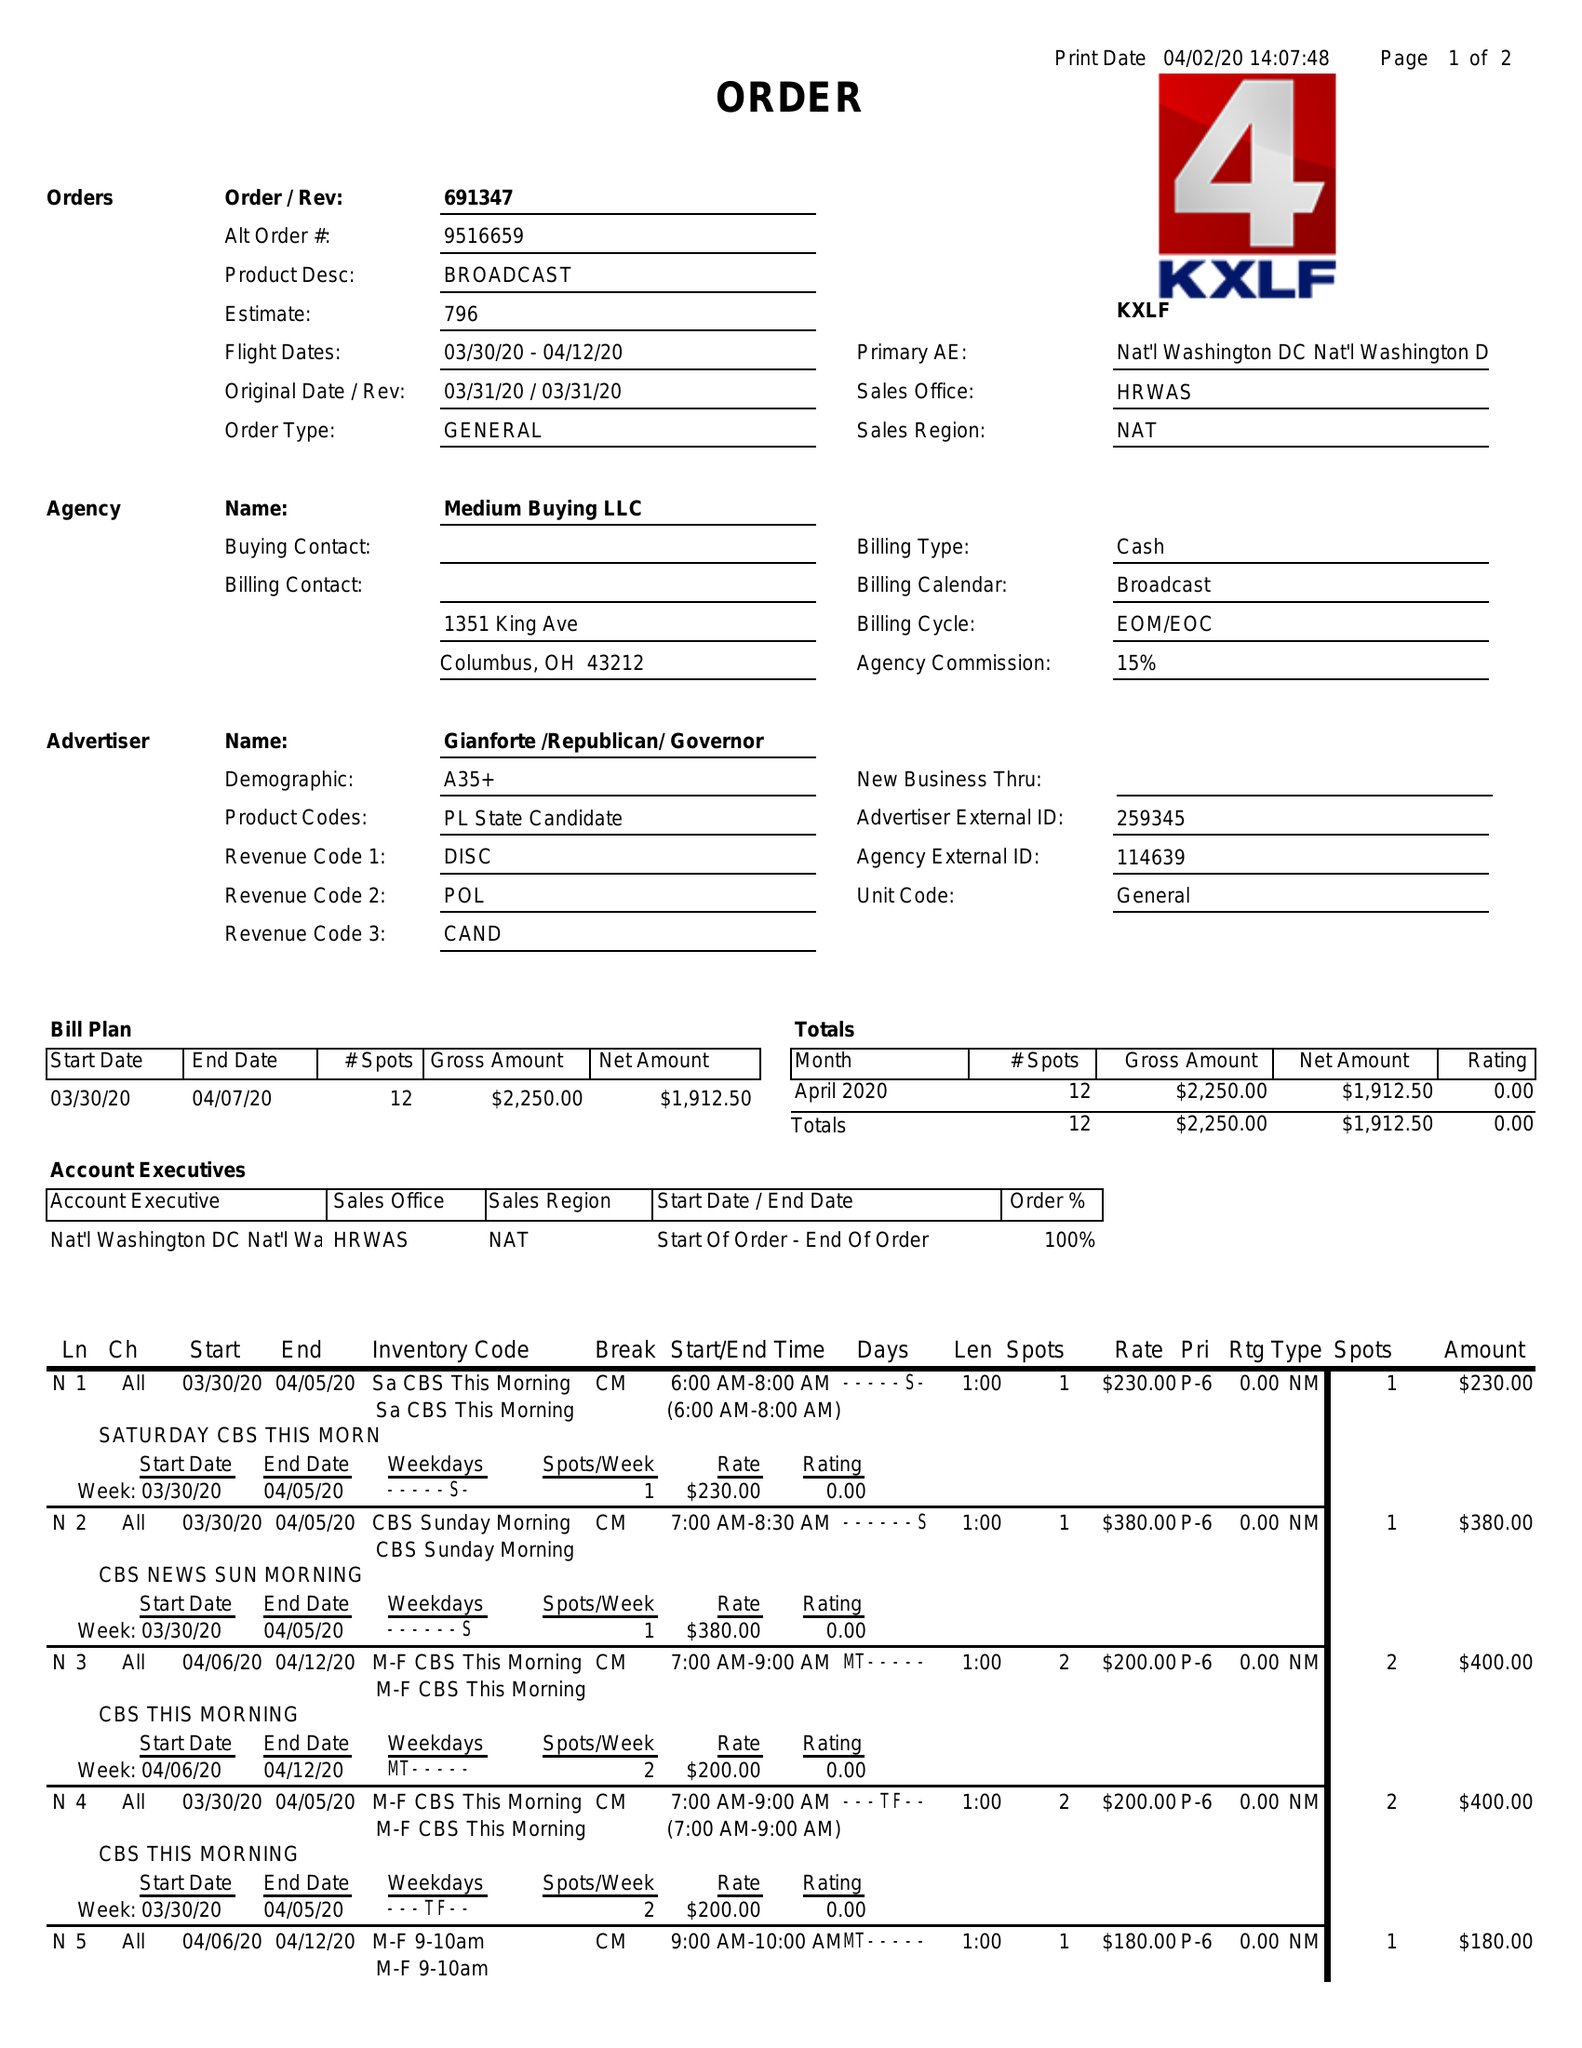What is the value for the advertiser?
Answer the question using a single word or phrase. GIANFORTE/REPUBLICAN/GOVERNOR 